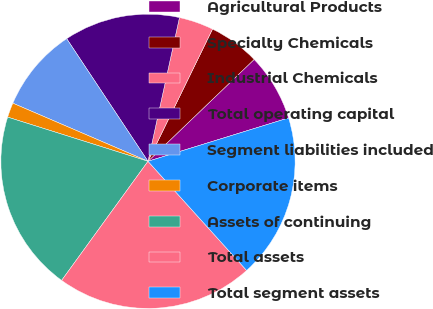Convert chart to OTSL. <chart><loc_0><loc_0><loc_500><loc_500><pie_chart><fcel>Agricultural Products<fcel>Specialty Chemicals<fcel>Industrial Chemicals<fcel>Total operating capital<fcel>Segment liabilities included<fcel>Corporate items<fcel>Assets of continuing<fcel>Total assets<fcel>Total segment assets<nl><fcel>7.41%<fcel>5.6%<fcel>3.8%<fcel>12.75%<fcel>9.22%<fcel>1.61%<fcel>19.87%<fcel>21.68%<fcel>18.07%<nl></chart> 